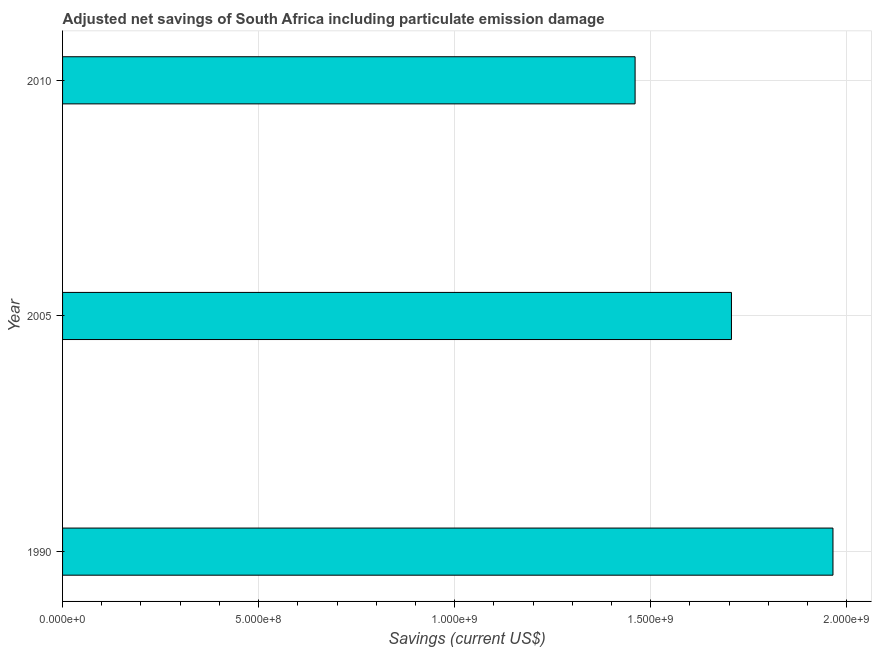Does the graph contain any zero values?
Provide a short and direct response. No. What is the title of the graph?
Your answer should be compact. Adjusted net savings of South Africa including particulate emission damage. What is the label or title of the X-axis?
Your answer should be compact. Savings (current US$). What is the label or title of the Y-axis?
Your answer should be very brief. Year. What is the adjusted net savings in 2005?
Your response must be concise. 1.71e+09. Across all years, what is the maximum adjusted net savings?
Make the answer very short. 1.96e+09. Across all years, what is the minimum adjusted net savings?
Your answer should be very brief. 1.46e+09. What is the sum of the adjusted net savings?
Offer a very short reply. 5.13e+09. What is the difference between the adjusted net savings in 1990 and 2005?
Ensure brevity in your answer.  2.59e+08. What is the average adjusted net savings per year?
Your answer should be compact. 1.71e+09. What is the median adjusted net savings?
Keep it short and to the point. 1.71e+09. Do a majority of the years between 2010 and 2005 (inclusive) have adjusted net savings greater than 100000000 US$?
Keep it short and to the point. No. What is the ratio of the adjusted net savings in 1990 to that in 2005?
Your answer should be compact. 1.15. Is the adjusted net savings in 1990 less than that in 2010?
Provide a succinct answer. No. What is the difference between the highest and the second highest adjusted net savings?
Ensure brevity in your answer.  2.59e+08. What is the difference between the highest and the lowest adjusted net savings?
Give a very brief answer. 5.05e+08. How many bars are there?
Offer a very short reply. 3. Are all the bars in the graph horizontal?
Give a very brief answer. Yes. How many years are there in the graph?
Give a very brief answer. 3. What is the Savings (current US$) in 1990?
Keep it short and to the point. 1.96e+09. What is the Savings (current US$) in 2005?
Ensure brevity in your answer.  1.71e+09. What is the Savings (current US$) of 2010?
Keep it short and to the point. 1.46e+09. What is the difference between the Savings (current US$) in 1990 and 2005?
Your response must be concise. 2.59e+08. What is the difference between the Savings (current US$) in 1990 and 2010?
Your response must be concise. 5.05e+08. What is the difference between the Savings (current US$) in 2005 and 2010?
Your response must be concise. 2.46e+08. What is the ratio of the Savings (current US$) in 1990 to that in 2005?
Your answer should be compact. 1.15. What is the ratio of the Savings (current US$) in 1990 to that in 2010?
Offer a terse response. 1.35. What is the ratio of the Savings (current US$) in 2005 to that in 2010?
Provide a succinct answer. 1.17. 